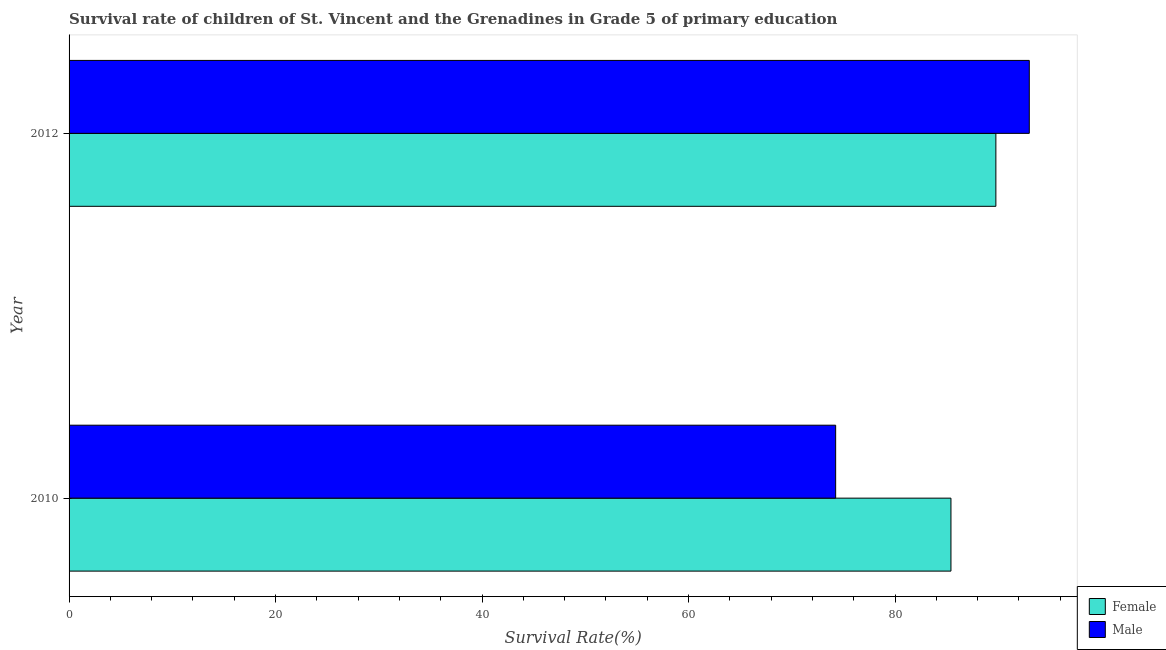How many different coloured bars are there?
Ensure brevity in your answer.  2. How many groups of bars are there?
Offer a terse response. 2. Are the number of bars per tick equal to the number of legend labels?
Ensure brevity in your answer.  Yes. How many bars are there on the 1st tick from the top?
Your answer should be compact. 2. What is the label of the 1st group of bars from the top?
Offer a terse response. 2012. What is the survival rate of male students in primary education in 2010?
Make the answer very short. 74.25. Across all years, what is the maximum survival rate of female students in primary education?
Your answer should be very brief. 89.77. Across all years, what is the minimum survival rate of male students in primary education?
Your answer should be compact. 74.25. In which year was the survival rate of male students in primary education maximum?
Keep it short and to the point. 2012. What is the total survival rate of male students in primary education in the graph?
Your answer should be very brief. 167.26. What is the difference between the survival rate of male students in primary education in 2010 and that in 2012?
Your response must be concise. -18.75. What is the difference between the survival rate of male students in primary education in 2010 and the survival rate of female students in primary education in 2012?
Make the answer very short. -15.52. What is the average survival rate of female students in primary education per year?
Keep it short and to the point. 87.59. In the year 2012, what is the difference between the survival rate of male students in primary education and survival rate of female students in primary education?
Provide a short and direct response. 3.24. In how many years, is the survival rate of male students in primary education greater than 32 %?
Ensure brevity in your answer.  2. Is the difference between the survival rate of female students in primary education in 2010 and 2012 greater than the difference between the survival rate of male students in primary education in 2010 and 2012?
Your answer should be very brief. Yes. In how many years, is the survival rate of female students in primary education greater than the average survival rate of female students in primary education taken over all years?
Provide a succinct answer. 1. What does the 2nd bar from the bottom in 2012 represents?
Your answer should be very brief. Male. How many years are there in the graph?
Offer a very short reply. 2. Are the values on the major ticks of X-axis written in scientific E-notation?
Ensure brevity in your answer.  No. Where does the legend appear in the graph?
Make the answer very short. Bottom right. How many legend labels are there?
Keep it short and to the point. 2. What is the title of the graph?
Your response must be concise. Survival rate of children of St. Vincent and the Grenadines in Grade 5 of primary education. What is the label or title of the X-axis?
Your answer should be compact. Survival Rate(%). What is the Survival Rate(%) in Female in 2010?
Ensure brevity in your answer.  85.42. What is the Survival Rate(%) in Male in 2010?
Offer a terse response. 74.25. What is the Survival Rate(%) of Female in 2012?
Make the answer very short. 89.77. What is the Survival Rate(%) in Male in 2012?
Offer a terse response. 93.01. Across all years, what is the maximum Survival Rate(%) in Female?
Provide a succinct answer. 89.77. Across all years, what is the maximum Survival Rate(%) in Male?
Provide a short and direct response. 93.01. Across all years, what is the minimum Survival Rate(%) in Female?
Offer a very short reply. 85.42. Across all years, what is the minimum Survival Rate(%) of Male?
Keep it short and to the point. 74.25. What is the total Survival Rate(%) in Female in the graph?
Offer a very short reply. 175.19. What is the total Survival Rate(%) of Male in the graph?
Your response must be concise. 167.26. What is the difference between the Survival Rate(%) in Female in 2010 and that in 2012?
Your response must be concise. -4.35. What is the difference between the Survival Rate(%) of Male in 2010 and that in 2012?
Your answer should be very brief. -18.76. What is the difference between the Survival Rate(%) in Female in 2010 and the Survival Rate(%) in Male in 2012?
Your answer should be compact. -7.59. What is the average Survival Rate(%) of Female per year?
Offer a very short reply. 87.59. What is the average Survival Rate(%) in Male per year?
Your response must be concise. 83.63. In the year 2010, what is the difference between the Survival Rate(%) of Female and Survival Rate(%) of Male?
Provide a succinct answer. 11.17. In the year 2012, what is the difference between the Survival Rate(%) in Female and Survival Rate(%) in Male?
Your response must be concise. -3.24. What is the ratio of the Survival Rate(%) in Female in 2010 to that in 2012?
Keep it short and to the point. 0.95. What is the ratio of the Survival Rate(%) of Male in 2010 to that in 2012?
Give a very brief answer. 0.8. What is the difference between the highest and the second highest Survival Rate(%) in Female?
Offer a very short reply. 4.35. What is the difference between the highest and the second highest Survival Rate(%) of Male?
Provide a succinct answer. 18.76. What is the difference between the highest and the lowest Survival Rate(%) in Female?
Provide a short and direct response. 4.35. What is the difference between the highest and the lowest Survival Rate(%) of Male?
Keep it short and to the point. 18.76. 